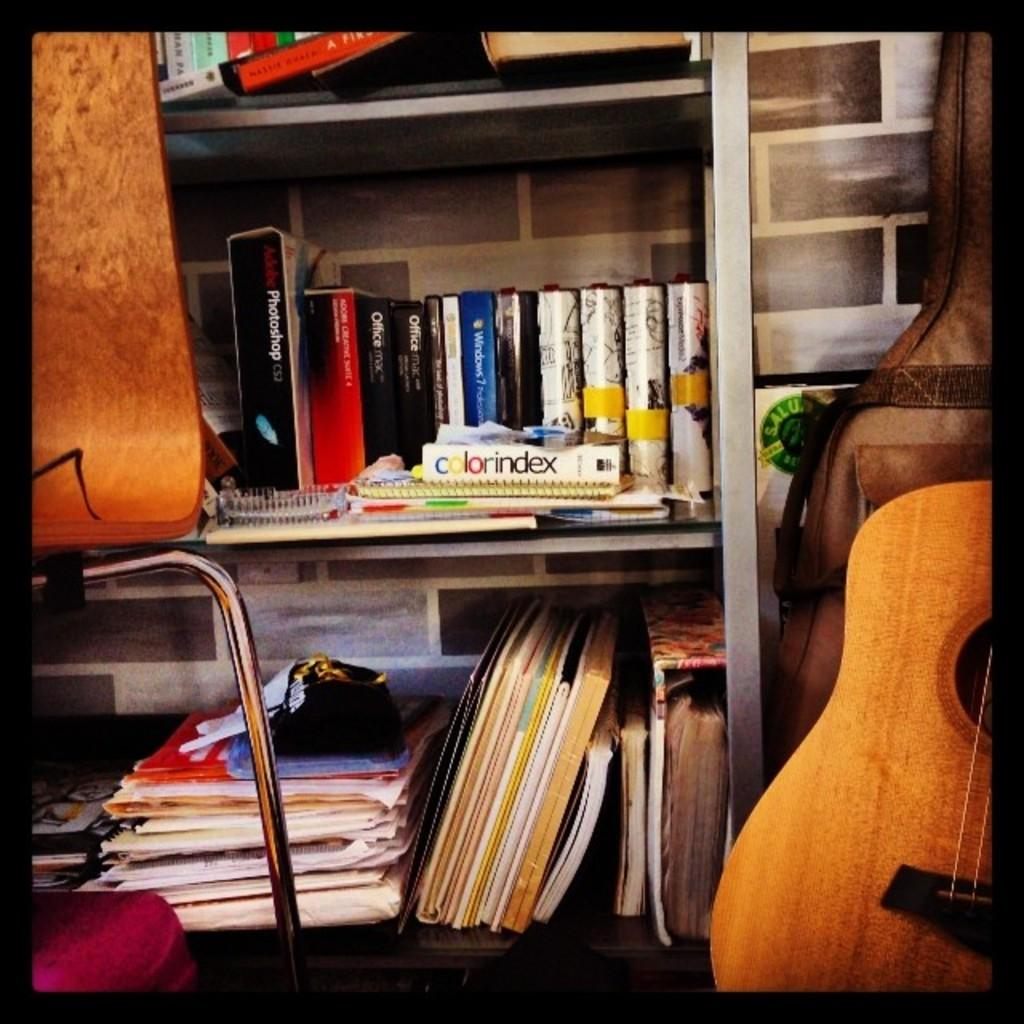Provide a one-sentence caption for the provided image. A book with the title Colorindex is sitting on a bookshelf with other books. 